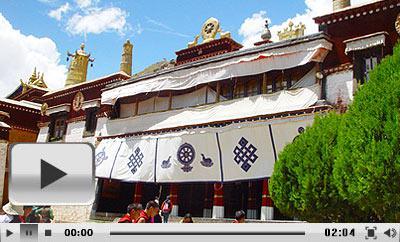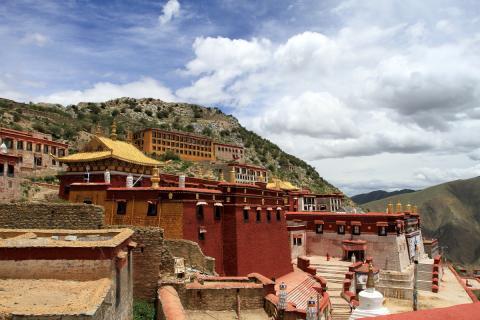The first image is the image on the left, the second image is the image on the right. Analyze the images presented: Is the assertion "In at least one image there are at least three homes dug in to the rocks facing forward and right." valid? Answer yes or no. Yes. 